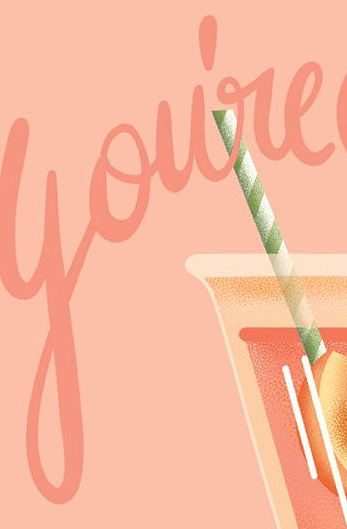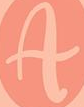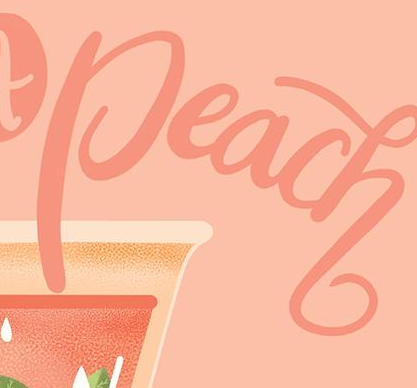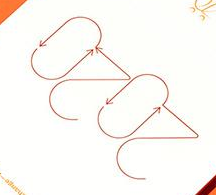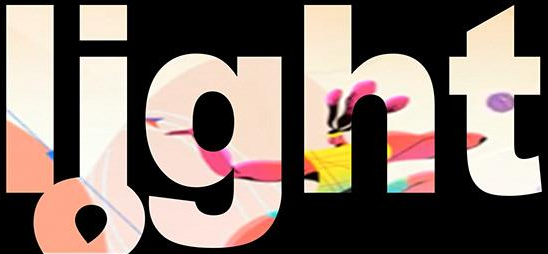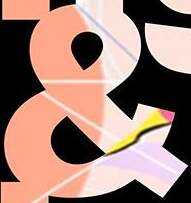Identify the words shown in these images in order, separated by a semicolon. You're; A; Peach; 2020; light; & 